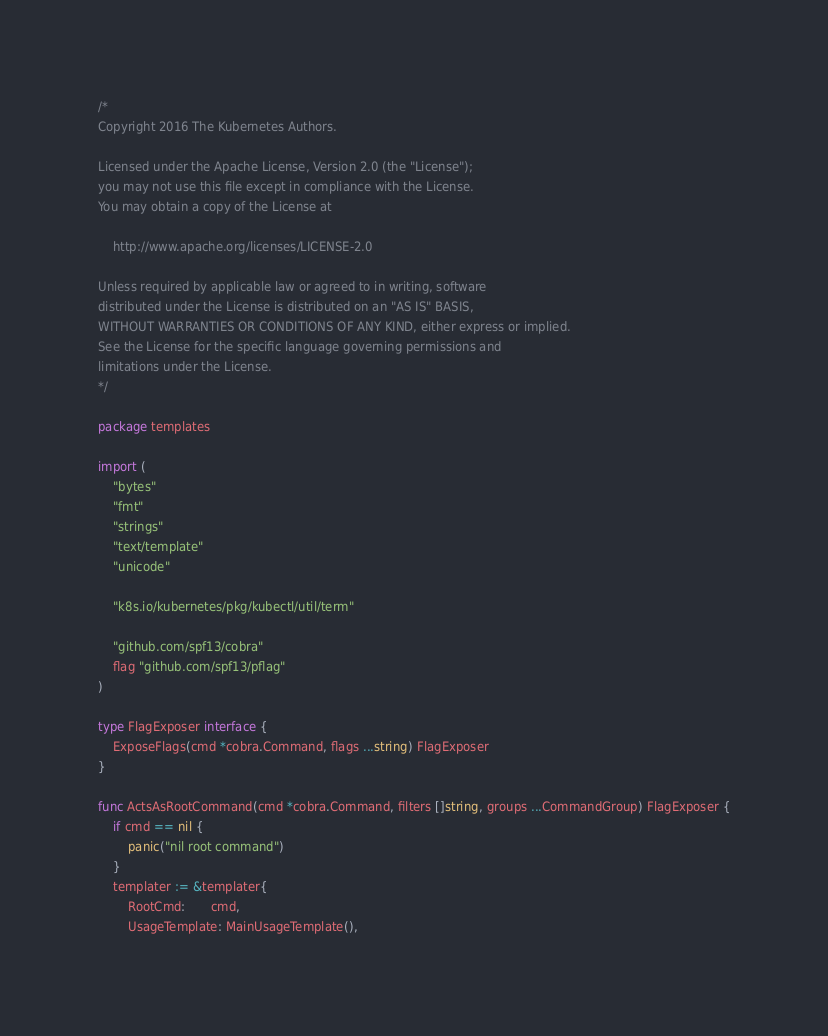Convert code to text. <code><loc_0><loc_0><loc_500><loc_500><_Go_>/*
Copyright 2016 The Kubernetes Authors.

Licensed under the Apache License, Version 2.0 (the "License");
you may not use this file except in compliance with the License.
You may obtain a copy of the License at

    http://www.apache.org/licenses/LICENSE-2.0

Unless required by applicable law or agreed to in writing, software
distributed under the License is distributed on an "AS IS" BASIS,
WITHOUT WARRANTIES OR CONDITIONS OF ANY KIND, either express or implied.
See the License for the specific language governing permissions and
limitations under the License.
*/

package templates

import (
	"bytes"
	"fmt"
	"strings"
	"text/template"
	"unicode"

	"k8s.io/kubernetes/pkg/kubectl/util/term"

	"github.com/spf13/cobra"
	flag "github.com/spf13/pflag"
)

type FlagExposer interface {
	ExposeFlags(cmd *cobra.Command, flags ...string) FlagExposer
}

func ActsAsRootCommand(cmd *cobra.Command, filters []string, groups ...CommandGroup) FlagExposer {
	if cmd == nil {
		panic("nil root command")
	}
	templater := &templater{
		RootCmd:       cmd,
		UsageTemplate: MainUsageTemplate(),</code> 